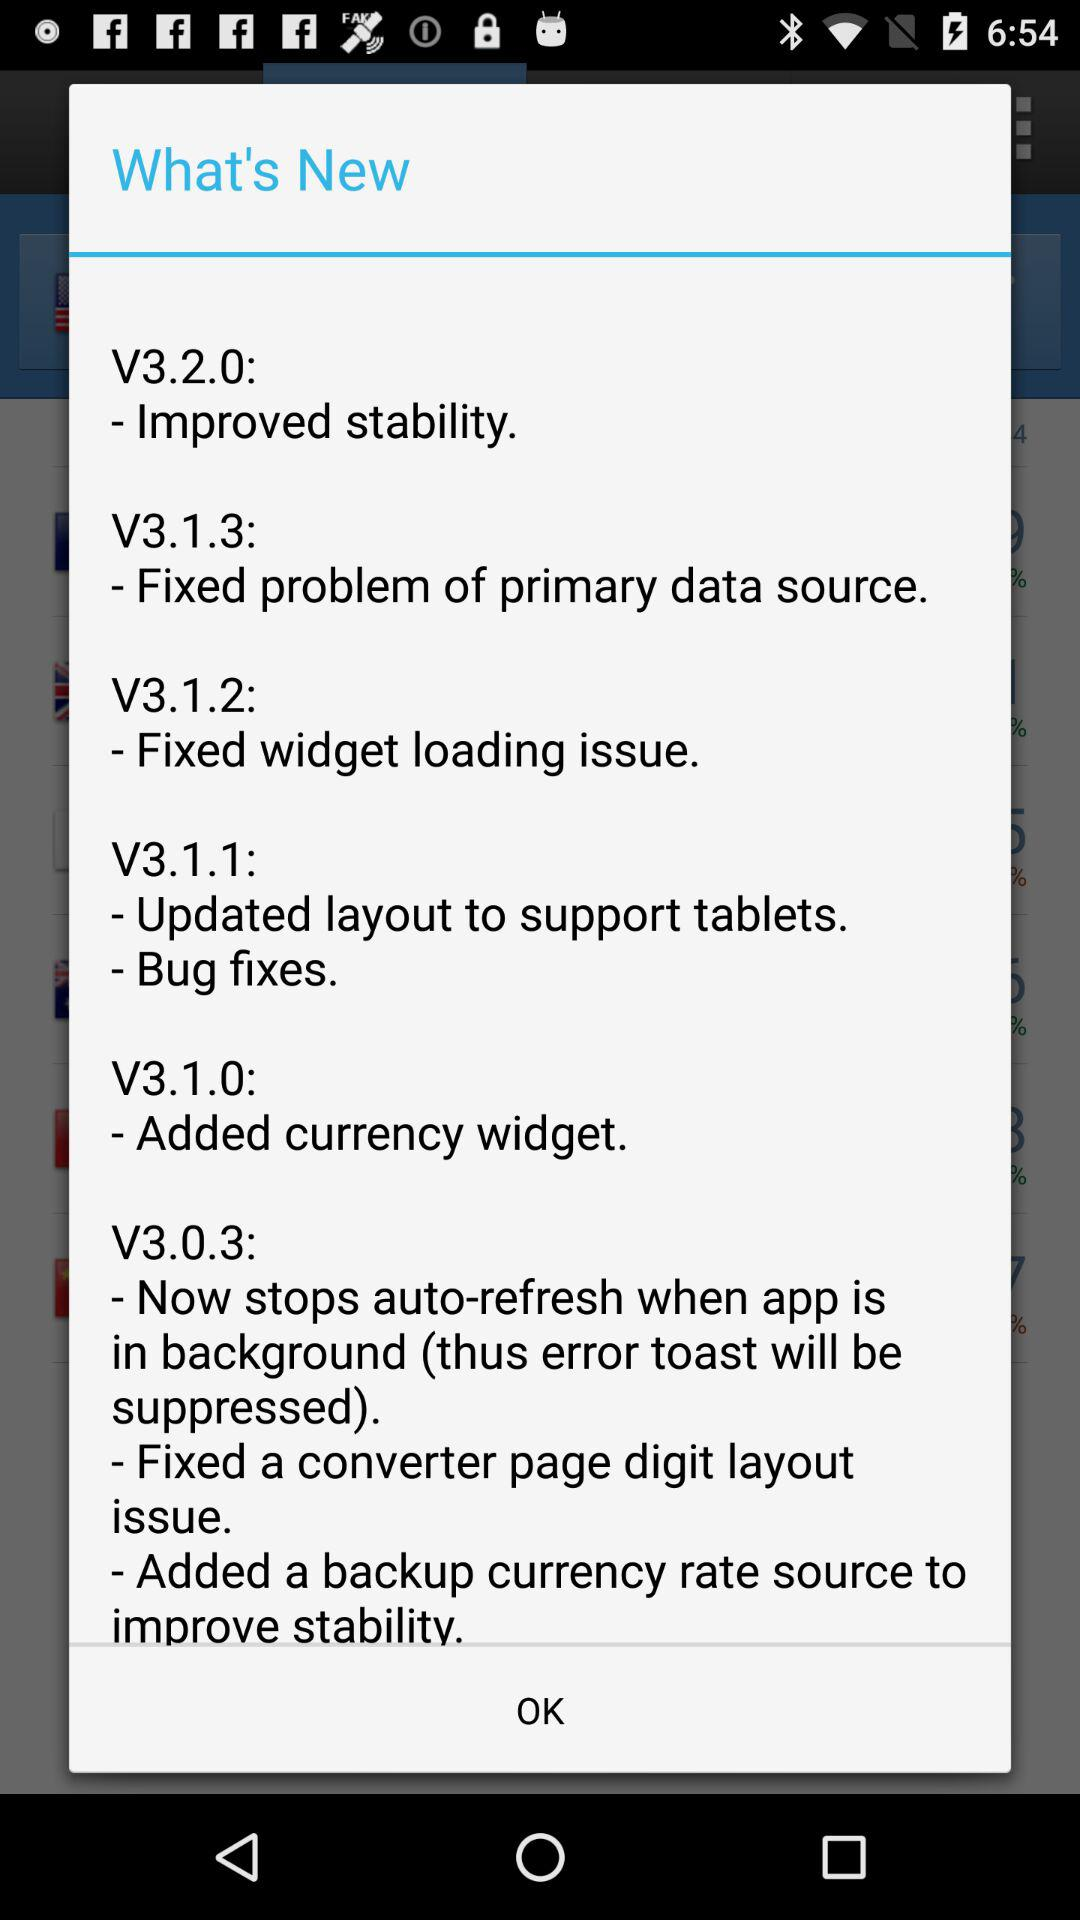Which version is the new feature "Fixed problem of primary data source" related to? The version is V3.1.3. 